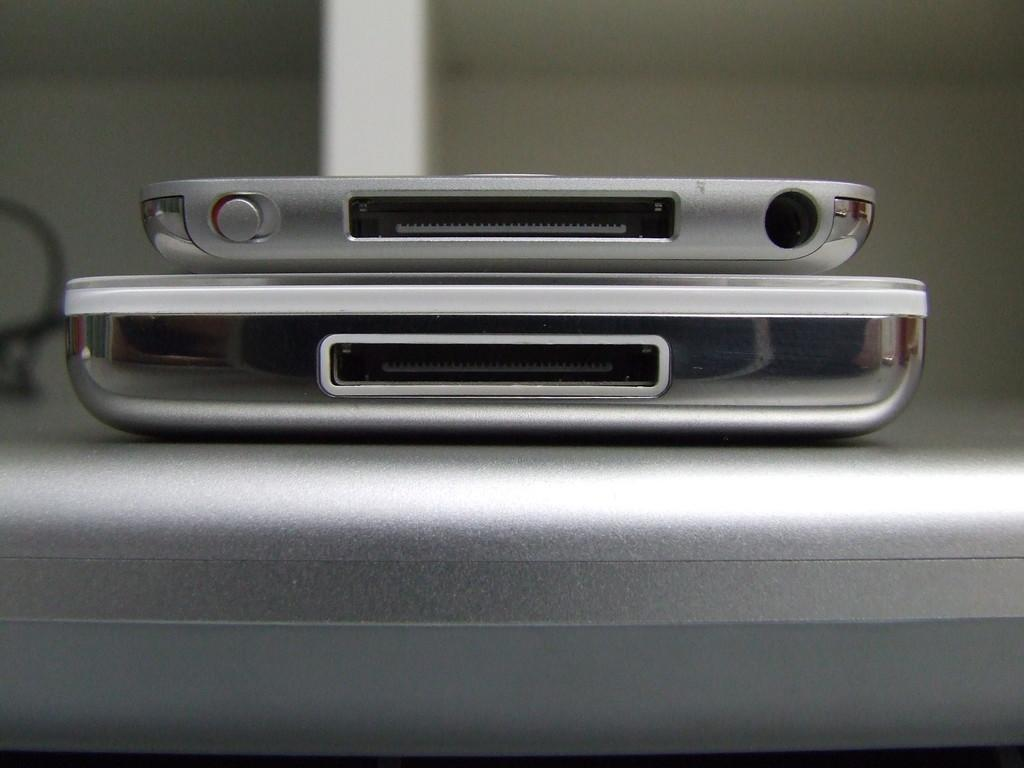What type of objects are present in the image? There are two machine items in the image. Where are the machine items located? The machine items are on a table. What type of cannon is visible on the roof in the image? There is no cannon or roof present in the image; it only features two machine items on a table. How many birds are perched on the machine items in the image? There are no birds present in the image; it only features two machine items on a table. 